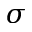<formula> <loc_0><loc_0><loc_500><loc_500>\sigma</formula> 